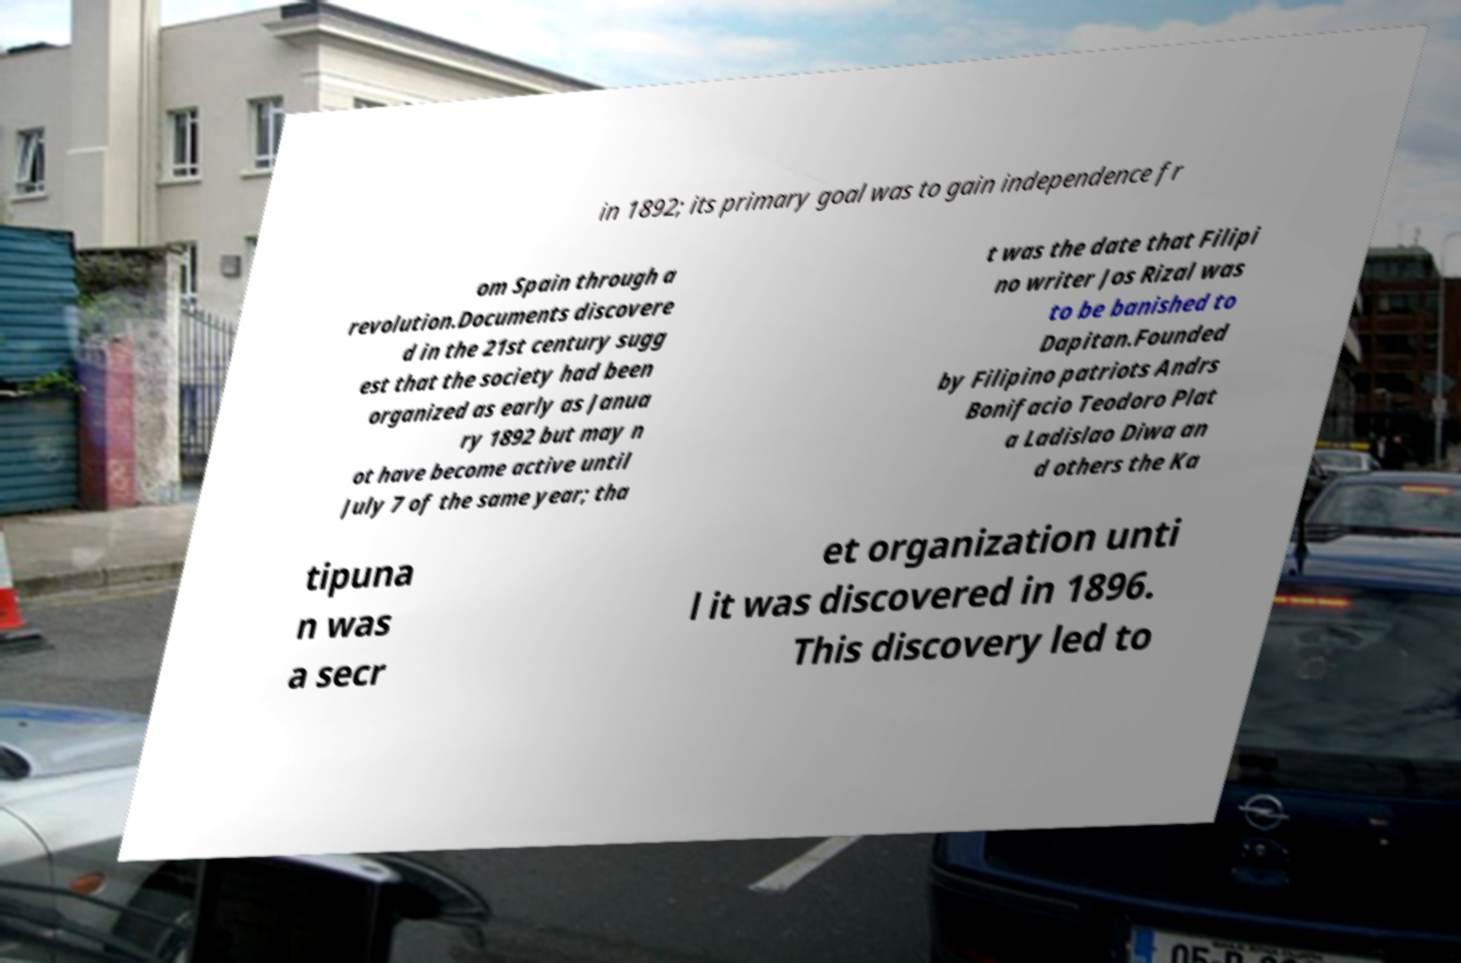Could you extract and type out the text from this image? in 1892; its primary goal was to gain independence fr om Spain through a revolution.Documents discovere d in the 21st century sugg est that the society had been organized as early as Janua ry 1892 but may n ot have become active until July 7 of the same year; tha t was the date that Filipi no writer Jos Rizal was to be banished to Dapitan.Founded by Filipino patriots Andrs Bonifacio Teodoro Plat a Ladislao Diwa an d others the Ka tipuna n was a secr et organization unti l it was discovered in 1896. This discovery led to 